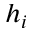Convert formula to latex. <formula><loc_0><loc_0><loc_500><loc_500>h _ { i }</formula> 